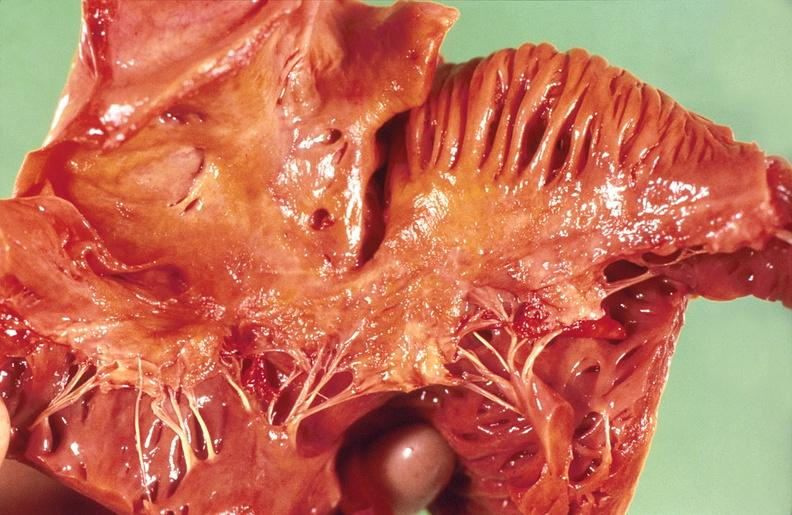where is this?
Answer the question using a single word or phrase. Heart 